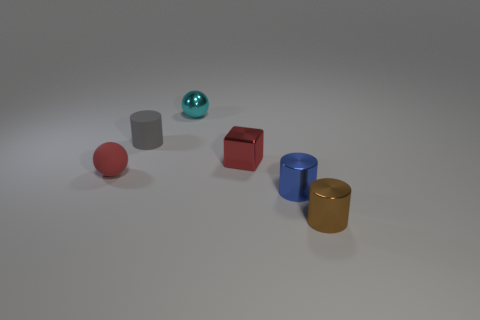How many things are either red rubber objects or tiny cylinders?
Make the answer very short. 4. Are there any other things of the same color as the small matte cylinder?
Keep it short and to the point. No. Is the material of the gray cylinder the same as the tiny red thing that is left of the gray object?
Provide a succinct answer. Yes. There is a tiny rubber object that is left of the cylinder left of the small blue cylinder; what is its shape?
Give a very brief answer. Sphere. What shape is the object that is both on the left side of the small cyan metallic ball and in front of the gray cylinder?
Provide a succinct answer. Sphere. How many things are big yellow cubes or red things left of the small cyan metallic sphere?
Your answer should be very brief. 1. What is the material of the blue object that is the same shape as the tiny gray object?
Your answer should be compact. Metal. Is there any other thing that has the same material as the gray cylinder?
Make the answer very short. Yes. There is a object that is both left of the small cyan shiny object and in front of the rubber cylinder; what is it made of?
Offer a terse response. Rubber. How many small cyan objects have the same shape as the tiny brown thing?
Provide a short and direct response. 0. 